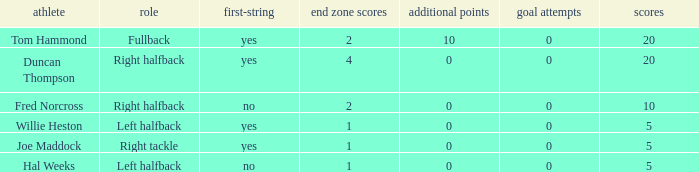How many touchdowns are there when there were 0 extra points and Hal Weeks had left halfback? 1.0. 